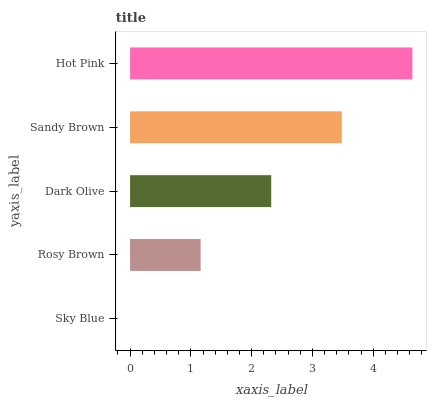Is Sky Blue the minimum?
Answer yes or no. Yes. Is Hot Pink the maximum?
Answer yes or no. Yes. Is Rosy Brown the minimum?
Answer yes or no. No. Is Rosy Brown the maximum?
Answer yes or no. No. Is Rosy Brown greater than Sky Blue?
Answer yes or no. Yes. Is Sky Blue less than Rosy Brown?
Answer yes or no. Yes. Is Sky Blue greater than Rosy Brown?
Answer yes or no. No. Is Rosy Brown less than Sky Blue?
Answer yes or no. No. Is Dark Olive the high median?
Answer yes or no. Yes. Is Dark Olive the low median?
Answer yes or no. Yes. Is Hot Pink the high median?
Answer yes or no. No. Is Sandy Brown the low median?
Answer yes or no. No. 